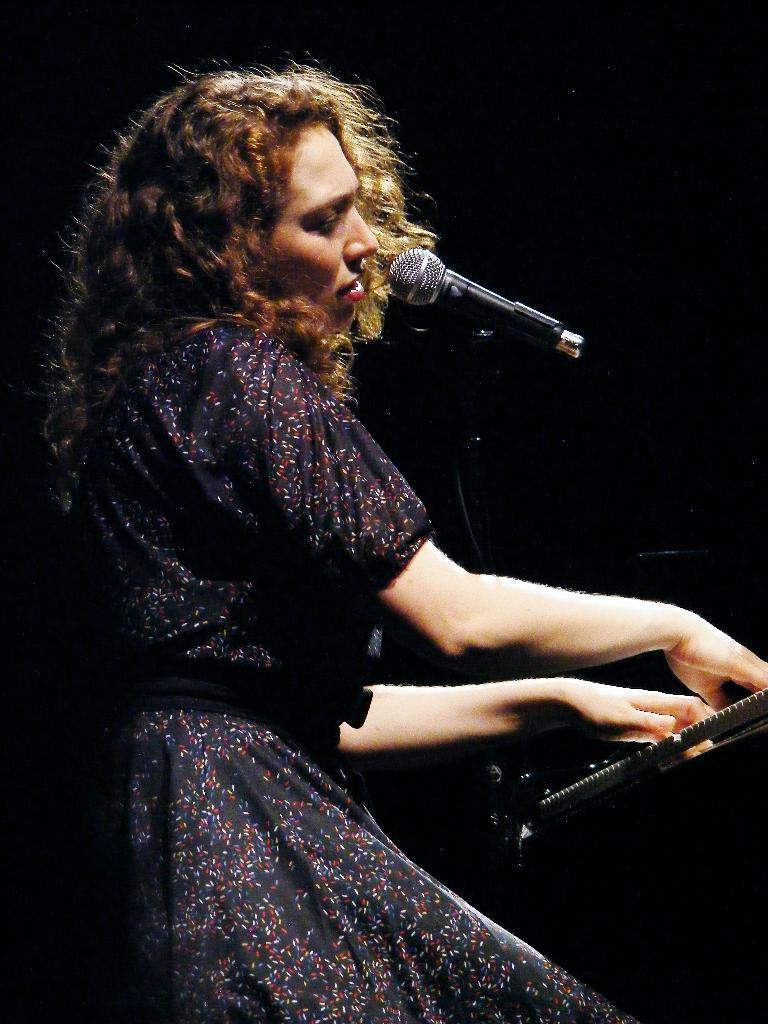Who is the main subject in the image? There is a woman in the image. What is the woman doing in the image? The woman is playing a keyboard. What other object is present in the image? There is a microphone in the image. What is the color of the background in the image? The background of the image is black. Where is the toothbrush located in the image? There is no toothbrush present in the image. Can you tell me what the dad is doing in the image? There is no dad present in the image; only a woman is visible. 